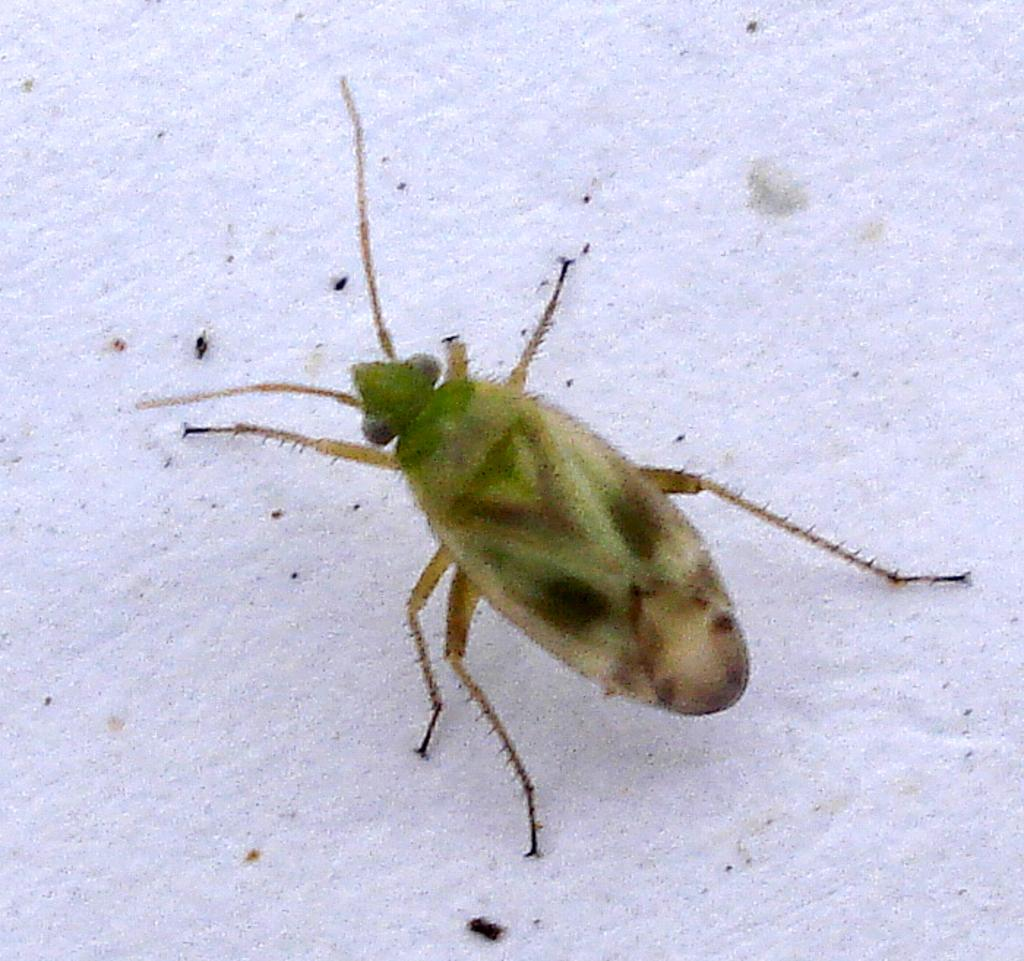What type of creature is in the image? There is an insect in the image. What colors can be seen on the insect? The insect has brown and green colors. What color is the background of the image? The background of the image is white. What type of brass instrument is the insect playing in the image? There is no brass instrument present in the image, and the insect is not playing any instrument. 